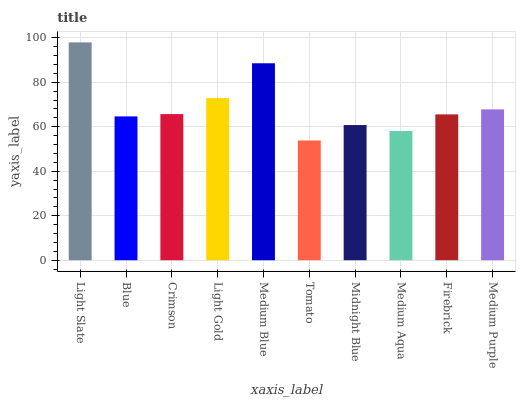Is Blue the minimum?
Answer yes or no. No. Is Blue the maximum?
Answer yes or no. No. Is Light Slate greater than Blue?
Answer yes or no. Yes. Is Blue less than Light Slate?
Answer yes or no. Yes. Is Blue greater than Light Slate?
Answer yes or no. No. Is Light Slate less than Blue?
Answer yes or no. No. Is Crimson the high median?
Answer yes or no. Yes. Is Firebrick the low median?
Answer yes or no. Yes. Is Midnight Blue the high median?
Answer yes or no. No. Is Medium Aqua the low median?
Answer yes or no. No. 